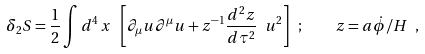<formula> <loc_0><loc_0><loc_500><loc_500>\delta _ { 2 } S = \frac { 1 } { 2 } \int d ^ { 4 } \, x \ \left [ \partial _ { \mu } u \partial ^ { \mu } u + z ^ { - 1 } \frac { d ^ { 2 } z } { d \tau ^ { 2 } } \ u ^ { 2 } \right ] \ ; \quad z = a \dot { \phi } / H \ ,</formula> 